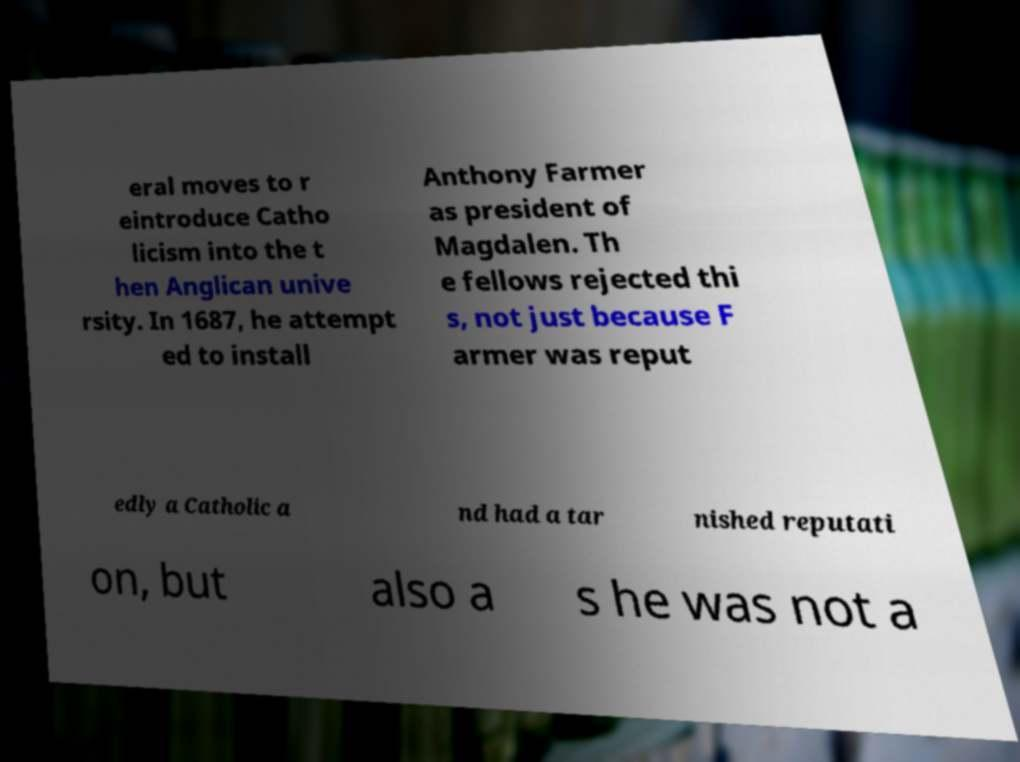Could you extract and type out the text from this image? eral moves to r eintroduce Catho licism into the t hen Anglican unive rsity. In 1687, he attempt ed to install Anthony Farmer as president of Magdalen. Th e fellows rejected thi s, not just because F armer was reput edly a Catholic a nd had a tar nished reputati on, but also a s he was not a 